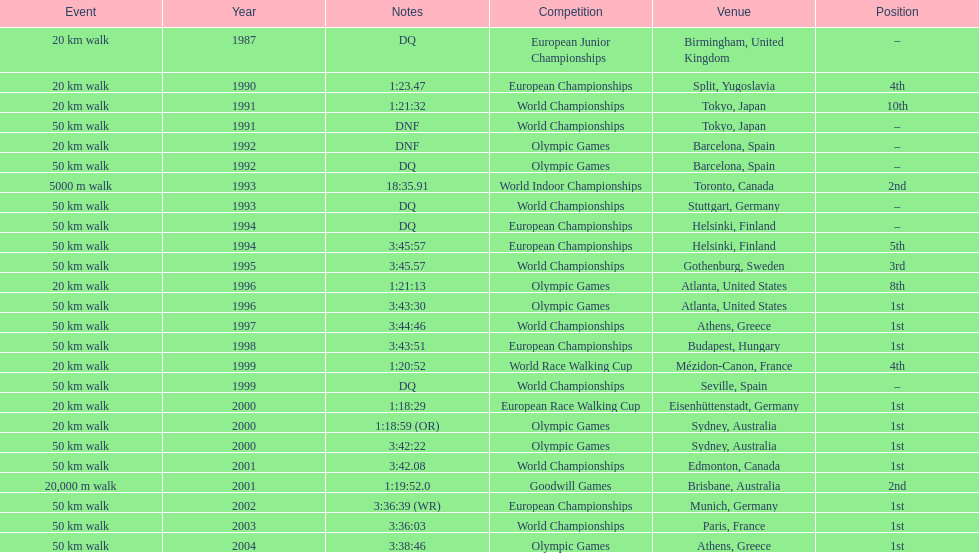Would you be able to parse every entry in this table? {'header': ['Event', 'Year', 'Notes', 'Competition', 'Venue', 'Position'], 'rows': [['20\xa0km walk', '1987', 'DQ', 'European Junior Championships', 'Birmingham, United Kingdom', '–'], ['20\xa0km walk', '1990', '1:23.47', 'European Championships', 'Split, Yugoslavia', '4th'], ['20\xa0km walk', '1991', '1:21:32', 'World Championships', 'Tokyo, Japan', '10th'], ['50\xa0km walk', '1991', 'DNF', 'World Championships', 'Tokyo, Japan', '–'], ['20\xa0km walk', '1992', 'DNF', 'Olympic Games', 'Barcelona, Spain', '–'], ['50\xa0km walk', '1992', 'DQ', 'Olympic Games', 'Barcelona, Spain', '–'], ['5000 m walk', '1993', '18:35.91', 'World Indoor Championships', 'Toronto, Canada', '2nd'], ['50\xa0km walk', '1993', 'DQ', 'World Championships', 'Stuttgart, Germany', '–'], ['50\xa0km walk', '1994', 'DQ', 'European Championships', 'Helsinki, Finland', '–'], ['50\xa0km walk', '1994', '3:45:57', 'European Championships', 'Helsinki, Finland', '5th'], ['50\xa0km walk', '1995', '3:45.57', 'World Championships', 'Gothenburg, Sweden', '3rd'], ['20\xa0km walk', '1996', '1:21:13', 'Olympic Games', 'Atlanta, United States', '8th'], ['50\xa0km walk', '1996', '3:43:30', 'Olympic Games', 'Atlanta, United States', '1st'], ['50\xa0km walk', '1997', '3:44:46', 'World Championships', 'Athens, Greece', '1st'], ['50\xa0km walk', '1998', '3:43:51', 'European Championships', 'Budapest, Hungary', '1st'], ['20\xa0km walk', '1999', '1:20:52', 'World Race Walking Cup', 'Mézidon-Canon, France', '4th'], ['50\xa0km walk', '1999', 'DQ', 'World Championships', 'Seville, Spain', '–'], ['20\xa0km walk', '2000', '1:18:29', 'European Race Walking Cup', 'Eisenhüttenstadt, Germany', '1st'], ['20\xa0km walk', '2000', '1:18:59 (OR)', 'Olympic Games', 'Sydney, Australia', '1st'], ['50\xa0km walk', '2000', '3:42:22', 'Olympic Games', 'Sydney, Australia', '1st'], ['50\xa0km walk', '2001', '3:42.08', 'World Championships', 'Edmonton, Canada', '1st'], ['20,000 m walk', '2001', '1:19:52.0', 'Goodwill Games', 'Brisbane, Australia', '2nd'], ['50\xa0km walk', '2002', '3:36:39 (WR)', 'European Championships', 'Munich, Germany', '1st'], ['50\xa0km walk', '2003', '3:36:03', 'World Championships', 'Paris, France', '1st'], ['50\xa0km walk', '2004', '3:38:46', 'Olympic Games', 'Athens, Greece', '1st']]} In what year was korzeniowski's last competition? 2004. 